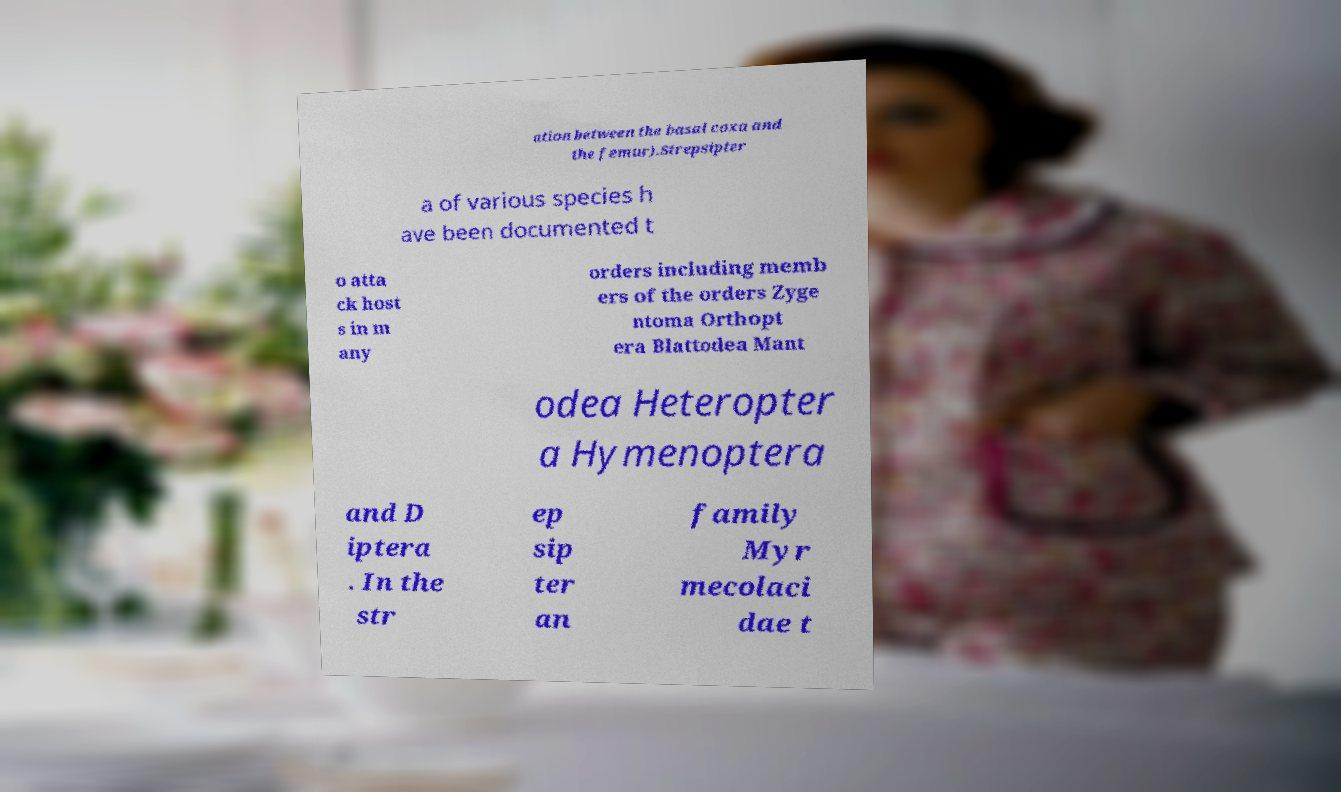Can you read and provide the text displayed in the image?This photo seems to have some interesting text. Can you extract and type it out for me? ation between the basal coxa and the femur).Strepsipter a of various species h ave been documented t o atta ck host s in m any orders including memb ers of the orders Zyge ntoma Orthopt era Blattodea Mant odea Heteropter a Hymenoptera and D iptera . In the str ep sip ter an family Myr mecolaci dae t 